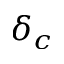<formula> <loc_0><loc_0><loc_500><loc_500>\delta _ { c }</formula> 